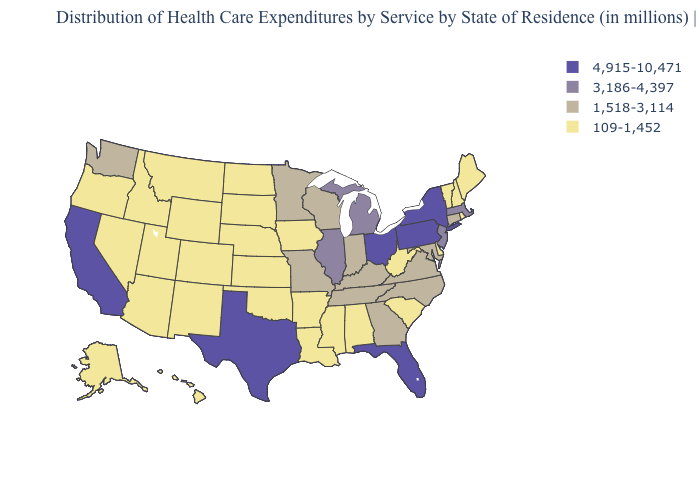What is the value of Alaska?
Write a very short answer. 109-1,452. What is the value of Hawaii?
Short answer required. 109-1,452. Is the legend a continuous bar?
Give a very brief answer. No. What is the value of Texas?
Answer briefly. 4,915-10,471. Does Pennsylvania have the highest value in the Northeast?
Give a very brief answer. Yes. What is the highest value in the USA?
Give a very brief answer. 4,915-10,471. Does the map have missing data?
Give a very brief answer. No. What is the value of New Hampshire?
Short answer required. 109-1,452. Name the states that have a value in the range 4,915-10,471?
Write a very short answer. California, Florida, New York, Ohio, Pennsylvania, Texas. Name the states that have a value in the range 4,915-10,471?
Write a very short answer. California, Florida, New York, Ohio, Pennsylvania, Texas. Among the states that border Alabama , which have the highest value?
Concise answer only. Florida. Does Illinois have the highest value in the USA?
Answer briefly. No. 